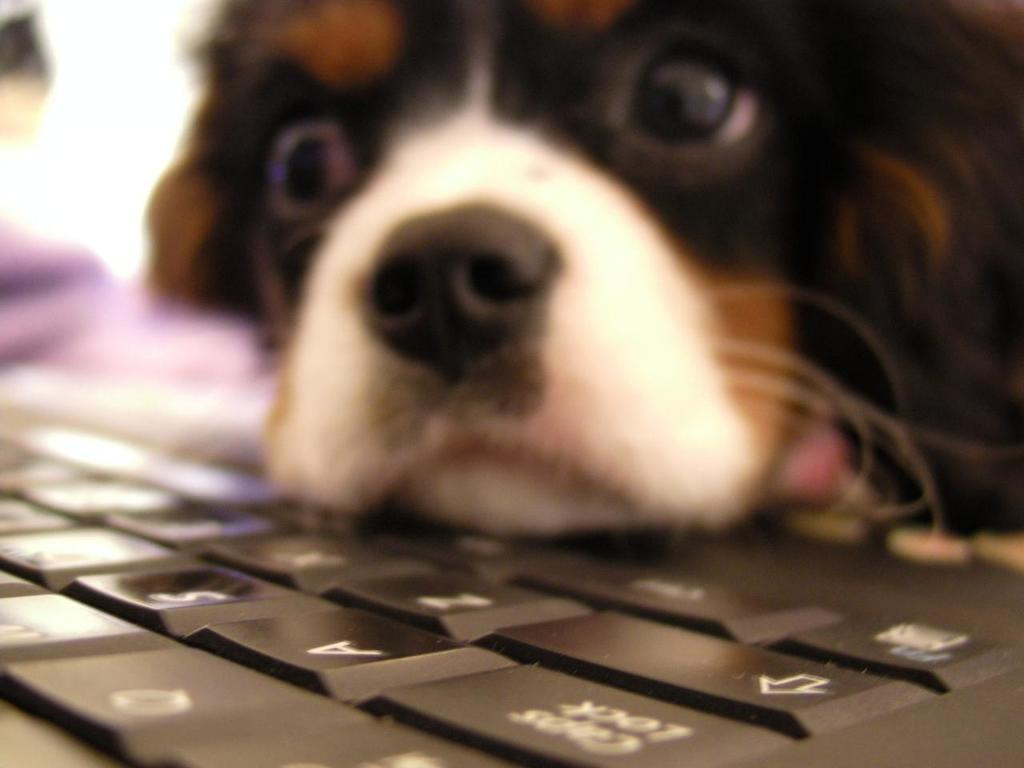What animal is the main subject of the image? There is a dog in the image. Where is the dog located in the image? The dog is in the center of the image. What is the dog's face on in the image? The dog's face is on a keyboard. Where is the keyboard placed in the image? The keyboard is placed at the bottom side of the image. How many rings are visible on the dog's tail in the image? There are no rings visible on the dog's tail in the image, as the dog's face is on a keyboard and its tail is not shown. 